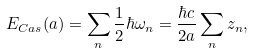Convert formula to latex. <formula><loc_0><loc_0><loc_500><loc_500>E _ { C a s } ( a ) = \sum _ { n } \frac { 1 } { 2 } \hbar { \omega } _ { n } = \frac { \hbar { c } } { 2 a } \sum _ { n } z _ { n } ,</formula> 